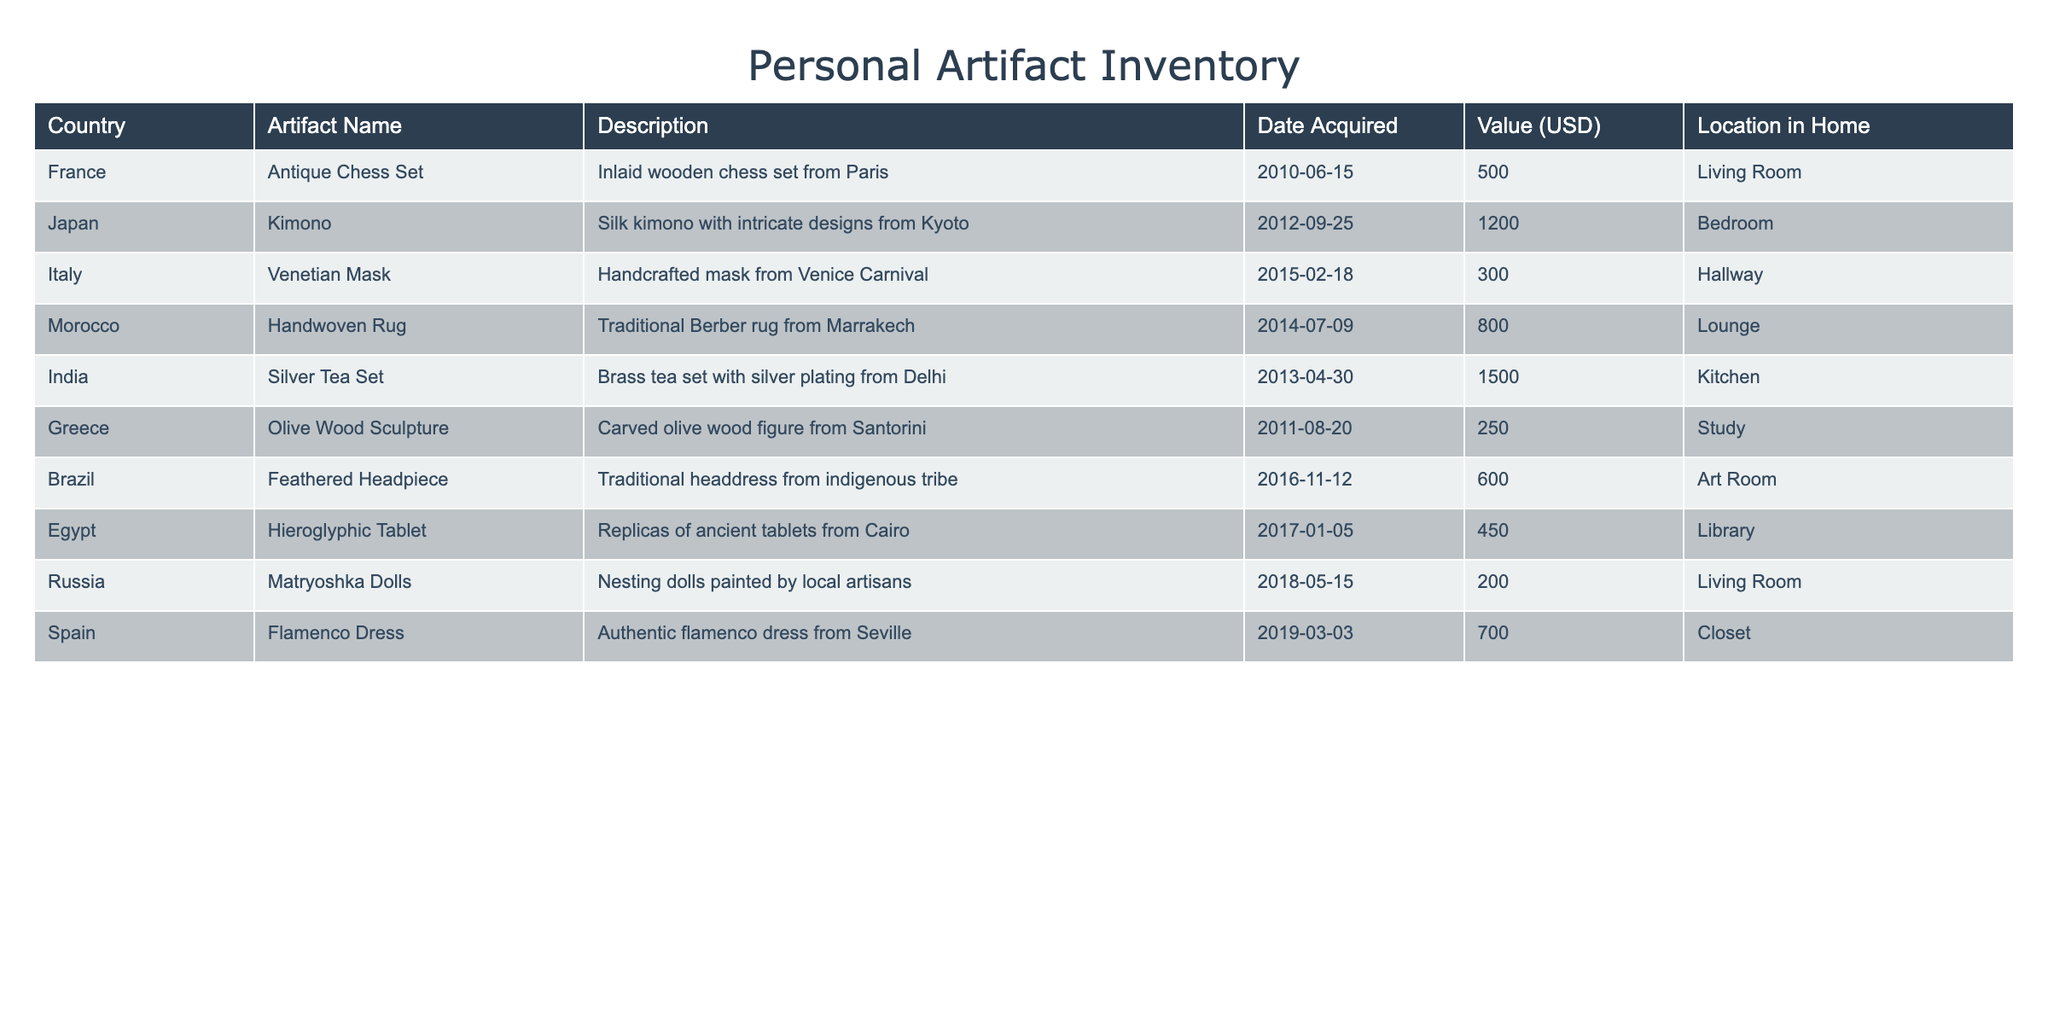What country is associated with the Antique Chess Set? The table lists the artifact along with its country of origin. By locating the row for the Antique Chess Set, we see that it is associated with France.
Answer: France Which artifact has the highest value? To find the artifact with the highest value, we can compare the values listed in the table. The Silver Tea Set from India has the highest value at 1500 USD.
Answer: Silver Tea Set How many artifacts were acquired in the year 2014? The table includes the Date Acquired for each artifact. By counting the rows where the year is 2014 (Handwoven Rug and not any other), we find that there are two artifacts acquired that year.
Answer: 2 What is the total value of artifacts acquired from countries in Europe? From the table, the European countries listed are France, Italy, Greece, Spain, and Russia. The values for the artifacts from these countries are: 500 (Antique Chess Set) + 300 (Venetian Mask) + 250 (Olive Wood Sculpture) + 700 (Flamenco Dress) + 200 (Matryoshka Dolls) = 1950 USD. Thus, the total value sums up to 1950 USD.
Answer: 1950 Did you acquire an artifact from Egypt? Checking the table for any artifacts listed from Egypt, we see that there is indeed a Hieroglyphic Tablet included in the inventory.
Answer: Yes What is the average value of all artifacts acquired? To find the average value, we sum the values of all artifacts and then divide by the number of artifacts. The total value is: 500 + 1200 + 300 + 800 + 1500 + 250 + 600 + 450 + 200 + 700 = 5450 USD, and there are 10 artifacts. So, the average value is 5450 / 10 = 545 USD.
Answer: 545 Which artifact is located in the study? By reviewing the Location in Home column, we identify that the Olive Wood Sculpture is the artifact located in the study.
Answer: Olive Wood Sculpture How many artifacts are there in total from Asia? The artifacts from Asia are the Kimono from Japan, the Silver Tea Set from India, and the Handwoven Rug from Morocco. Counting these, there are three artifacts listed from Asian countries in this inventory.
Answer: 3 